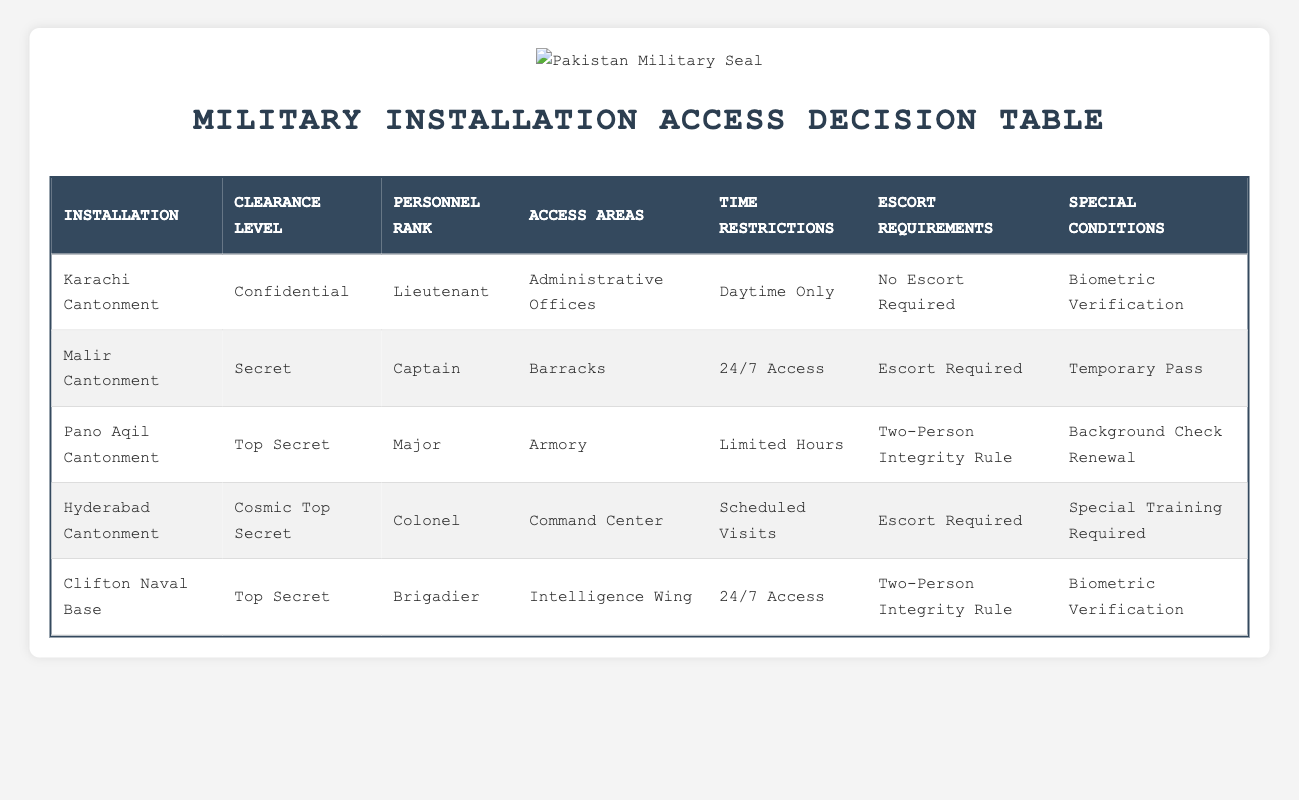What is the access area for personnel with Top Secret clearance at the Clifton Naval Base? According to the table, the Clifton Naval Base has personnel of rank Brigadier with Top Secret clearance, and the access area is noted as the Intelligence Wing.
Answer: Intelligence Wing Is there any installation where Barracks can be accessed by personnel of rank greater than Captain? The Malir Cantonment is the only installation listed where the access area is Barracks, which is for personnel of rank Captain only. Hence, no personnel of rank greater than Captain can access Barracks.
Answer: No What are the time restrictions for personnel with Cosmic Top Secret clearance at Hyderabad Cantonment? The table indicates that personnel with Cosmic Top Secret clearance at the Hyderabad Cantonment have scheduled visits as time restrictions.
Answer: Scheduled Visits How many installations allow 24/7 access? The installations allowing 24/7 access are Malir Cantonment and Clifton Naval Base, totaling to 2 installations.
Answer: 2 Is a special training required for access to the Command Center at Hyderabad Cantonment? The entry for Hyderabad Cantonment states that special training is required for access to the Command Center for personnel with Cosmic Top Secret clearance.
Answer: Yes What ranks can access the Armory, and what is the access area’s limitation for them? The Armory can be accessed by personnel with the rank of Major, who can do so during limited hours as indicated in the table.
Answer: Major, Limited Hours Which installation has the highest personnel rank accessing the Administrative Offices and what is the clearance level? The Karachi Cantonment has a Lieutenant accessing the Administrative Offices with a clearance level of Confidential, which is the lowest rank noted in the table.
Answer: Lieutenant, Confidential Do all personnel accessing the Intelligence Wing have the same clearance level? The table indicates that the only personnel accessing the Intelligence Wing at Clifton Naval Base is a Brigadier with Top Secret clearance, meaning not all personnel have the same clearance level.
Answer: No 